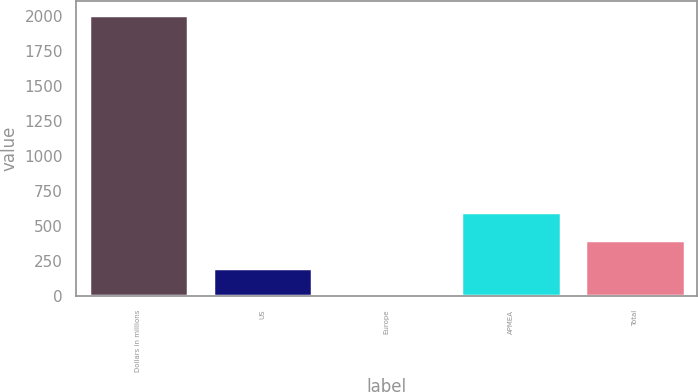<chart> <loc_0><loc_0><loc_500><loc_500><bar_chart><fcel>Dollars in millions<fcel>US<fcel>Europe<fcel>APMEA<fcel>Total<nl><fcel>2009<fcel>201.8<fcel>1<fcel>603.4<fcel>402.6<nl></chart> 